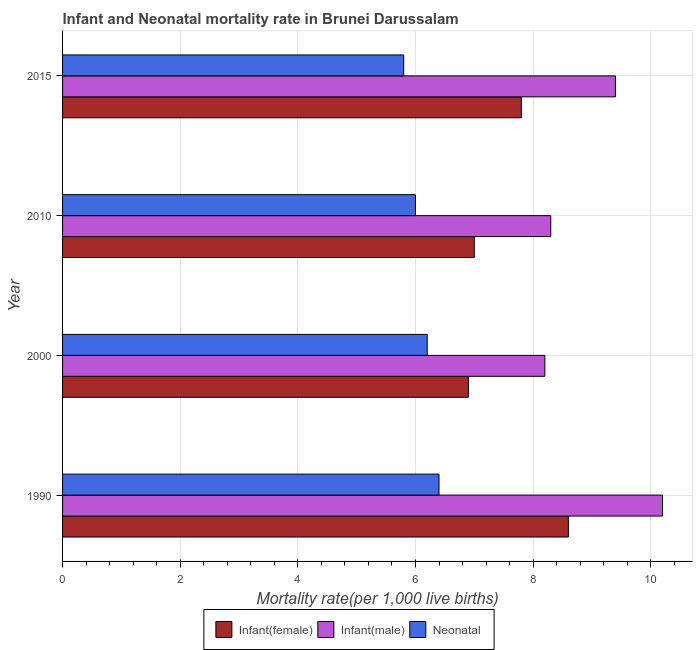Are the number of bars per tick equal to the number of legend labels?
Your answer should be very brief. Yes. Are the number of bars on each tick of the Y-axis equal?
Provide a short and direct response. Yes. What is the label of the 1st group of bars from the top?
Your answer should be compact. 2015. In how many cases, is the number of bars for a given year not equal to the number of legend labels?
Offer a very short reply. 0. Across all years, what is the maximum neonatal mortality rate?
Provide a succinct answer. 6.4. Across all years, what is the minimum infant mortality rate(male)?
Ensure brevity in your answer.  8.2. What is the total infant mortality rate(female) in the graph?
Give a very brief answer. 30.3. What is the difference between the infant mortality rate(female) in 2000 and the infant mortality rate(male) in 2015?
Make the answer very short. -2.5. What is the average infant mortality rate(male) per year?
Offer a very short reply. 9.03. In how many years, is the neonatal mortality rate greater than 2.8 ?
Provide a short and direct response. 4. What is the ratio of the infant mortality rate(male) in 2000 to that in 2015?
Your answer should be compact. 0.87. Is the difference between the infant mortality rate(female) in 1990 and 2010 greater than the difference between the infant mortality rate(male) in 1990 and 2010?
Your answer should be very brief. No. What is the difference between the highest and the lowest infant mortality rate(female)?
Your response must be concise. 1.7. Is the sum of the neonatal mortality rate in 1990 and 2015 greater than the maximum infant mortality rate(male) across all years?
Your response must be concise. Yes. What does the 2nd bar from the top in 1990 represents?
Your answer should be compact. Infant(male). What does the 2nd bar from the bottom in 2010 represents?
Make the answer very short. Infant(male). Is it the case that in every year, the sum of the infant mortality rate(female) and infant mortality rate(male) is greater than the neonatal mortality rate?
Keep it short and to the point. Yes. How many bars are there?
Your response must be concise. 12. Are all the bars in the graph horizontal?
Your answer should be compact. Yes. What is the difference between two consecutive major ticks on the X-axis?
Provide a succinct answer. 2. How many legend labels are there?
Your answer should be very brief. 3. How are the legend labels stacked?
Provide a succinct answer. Horizontal. What is the title of the graph?
Ensure brevity in your answer.  Infant and Neonatal mortality rate in Brunei Darussalam. Does "Capital account" appear as one of the legend labels in the graph?
Your response must be concise. No. What is the label or title of the X-axis?
Offer a very short reply. Mortality rate(per 1,0 live births). What is the Mortality rate(per 1,000 live births) in Infant(male) in 1990?
Your answer should be compact. 10.2. What is the Mortality rate(per 1,000 live births) in Infant(female) in 2000?
Your response must be concise. 6.9. What is the Mortality rate(per 1,000 live births) in Infant(male) in 2000?
Offer a terse response. 8.2. What is the Mortality rate(per 1,000 live births) of Infant(female) in 2015?
Ensure brevity in your answer.  7.8. What is the Mortality rate(per 1,000 live births) in Infant(male) in 2015?
Provide a succinct answer. 9.4. What is the Mortality rate(per 1,000 live births) in Neonatal  in 2015?
Offer a very short reply. 5.8. Across all years, what is the maximum Mortality rate(per 1,000 live births) in Infant(male)?
Your response must be concise. 10.2. Across all years, what is the minimum Mortality rate(per 1,000 live births) of Infant(female)?
Give a very brief answer. 6.9. Across all years, what is the minimum Mortality rate(per 1,000 live births) in Infant(male)?
Your answer should be compact. 8.2. Across all years, what is the minimum Mortality rate(per 1,000 live births) in Neonatal ?
Your answer should be very brief. 5.8. What is the total Mortality rate(per 1,000 live births) in Infant(female) in the graph?
Your response must be concise. 30.3. What is the total Mortality rate(per 1,000 live births) in Infant(male) in the graph?
Provide a succinct answer. 36.1. What is the total Mortality rate(per 1,000 live births) of Neonatal  in the graph?
Ensure brevity in your answer.  24.4. What is the difference between the Mortality rate(per 1,000 live births) in Infant(female) in 1990 and that in 2000?
Keep it short and to the point. 1.7. What is the difference between the Mortality rate(per 1,000 live births) in Infant(male) in 1990 and that in 2000?
Your answer should be compact. 2. What is the difference between the Mortality rate(per 1,000 live births) in Infant(female) in 1990 and that in 2010?
Make the answer very short. 1.6. What is the difference between the Mortality rate(per 1,000 live births) of Infant(female) in 2000 and that in 2010?
Your answer should be very brief. -0.1. What is the difference between the Mortality rate(per 1,000 live births) in Infant(female) in 2000 and that in 2015?
Offer a terse response. -0.9. What is the difference between the Mortality rate(per 1,000 live births) in Infant(male) in 2000 and that in 2015?
Give a very brief answer. -1.2. What is the difference between the Mortality rate(per 1,000 live births) in Neonatal  in 2000 and that in 2015?
Your answer should be compact. 0.4. What is the difference between the Mortality rate(per 1,000 live births) of Neonatal  in 2010 and that in 2015?
Offer a terse response. 0.2. What is the difference between the Mortality rate(per 1,000 live births) of Infant(female) in 1990 and the Mortality rate(per 1,000 live births) of Neonatal  in 2010?
Provide a short and direct response. 2.6. What is the difference between the Mortality rate(per 1,000 live births) in Infant(female) in 1990 and the Mortality rate(per 1,000 live births) in Neonatal  in 2015?
Offer a very short reply. 2.8. What is the difference between the Mortality rate(per 1,000 live births) in Infant(female) in 2000 and the Mortality rate(per 1,000 live births) in Neonatal  in 2010?
Give a very brief answer. 0.9. What is the difference between the Mortality rate(per 1,000 live births) of Infant(male) in 2010 and the Mortality rate(per 1,000 live births) of Neonatal  in 2015?
Provide a short and direct response. 2.5. What is the average Mortality rate(per 1,000 live births) in Infant(female) per year?
Keep it short and to the point. 7.58. What is the average Mortality rate(per 1,000 live births) in Infant(male) per year?
Make the answer very short. 9.03. In the year 1990, what is the difference between the Mortality rate(per 1,000 live births) of Infant(female) and Mortality rate(per 1,000 live births) of Neonatal ?
Your answer should be very brief. 2.2. In the year 1990, what is the difference between the Mortality rate(per 1,000 live births) in Infant(male) and Mortality rate(per 1,000 live births) in Neonatal ?
Offer a very short reply. 3.8. In the year 2000, what is the difference between the Mortality rate(per 1,000 live births) of Infant(female) and Mortality rate(per 1,000 live births) of Infant(male)?
Give a very brief answer. -1.3. In the year 2000, what is the difference between the Mortality rate(per 1,000 live births) in Infant(female) and Mortality rate(per 1,000 live births) in Neonatal ?
Your answer should be very brief. 0.7. In the year 2000, what is the difference between the Mortality rate(per 1,000 live births) in Infant(male) and Mortality rate(per 1,000 live births) in Neonatal ?
Your answer should be very brief. 2. In the year 2010, what is the difference between the Mortality rate(per 1,000 live births) in Infant(female) and Mortality rate(per 1,000 live births) in Infant(male)?
Offer a terse response. -1.3. In the year 2015, what is the difference between the Mortality rate(per 1,000 live births) of Infant(female) and Mortality rate(per 1,000 live births) of Neonatal ?
Offer a very short reply. 2. In the year 2015, what is the difference between the Mortality rate(per 1,000 live births) of Infant(male) and Mortality rate(per 1,000 live births) of Neonatal ?
Your response must be concise. 3.6. What is the ratio of the Mortality rate(per 1,000 live births) of Infant(female) in 1990 to that in 2000?
Keep it short and to the point. 1.25. What is the ratio of the Mortality rate(per 1,000 live births) in Infant(male) in 1990 to that in 2000?
Give a very brief answer. 1.24. What is the ratio of the Mortality rate(per 1,000 live births) in Neonatal  in 1990 to that in 2000?
Provide a succinct answer. 1.03. What is the ratio of the Mortality rate(per 1,000 live births) of Infant(female) in 1990 to that in 2010?
Offer a very short reply. 1.23. What is the ratio of the Mortality rate(per 1,000 live births) of Infant(male) in 1990 to that in 2010?
Provide a short and direct response. 1.23. What is the ratio of the Mortality rate(per 1,000 live births) in Neonatal  in 1990 to that in 2010?
Offer a terse response. 1.07. What is the ratio of the Mortality rate(per 1,000 live births) in Infant(female) in 1990 to that in 2015?
Make the answer very short. 1.1. What is the ratio of the Mortality rate(per 1,000 live births) in Infant(male) in 1990 to that in 2015?
Your answer should be compact. 1.09. What is the ratio of the Mortality rate(per 1,000 live births) of Neonatal  in 1990 to that in 2015?
Provide a short and direct response. 1.1. What is the ratio of the Mortality rate(per 1,000 live births) of Infant(female) in 2000 to that in 2010?
Provide a short and direct response. 0.99. What is the ratio of the Mortality rate(per 1,000 live births) of Infant(male) in 2000 to that in 2010?
Ensure brevity in your answer.  0.99. What is the ratio of the Mortality rate(per 1,000 live births) of Infant(female) in 2000 to that in 2015?
Your answer should be compact. 0.88. What is the ratio of the Mortality rate(per 1,000 live births) of Infant(male) in 2000 to that in 2015?
Your response must be concise. 0.87. What is the ratio of the Mortality rate(per 1,000 live births) of Neonatal  in 2000 to that in 2015?
Give a very brief answer. 1.07. What is the ratio of the Mortality rate(per 1,000 live births) in Infant(female) in 2010 to that in 2015?
Provide a succinct answer. 0.9. What is the ratio of the Mortality rate(per 1,000 live births) in Infant(male) in 2010 to that in 2015?
Your answer should be compact. 0.88. What is the ratio of the Mortality rate(per 1,000 live births) of Neonatal  in 2010 to that in 2015?
Ensure brevity in your answer.  1.03. What is the difference between the highest and the second highest Mortality rate(per 1,000 live births) in Infant(female)?
Offer a terse response. 0.8. What is the difference between the highest and the second highest Mortality rate(per 1,000 live births) of Infant(male)?
Provide a short and direct response. 0.8. What is the difference between the highest and the second highest Mortality rate(per 1,000 live births) in Neonatal ?
Keep it short and to the point. 0.2. What is the difference between the highest and the lowest Mortality rate(per 1,000 live births) in Infant(female)?
Your answer should be very brief. 1.7. What is the difference between the highest and the lowest Mortality rate(per 1,000 live births) of Infant(male)?
Your answer should be very brief. 2. What is the difference between the highest and the lowest Mortality rate(per 1,000 live births) of Neonatal ?
Offer a terse response. 0.6. 